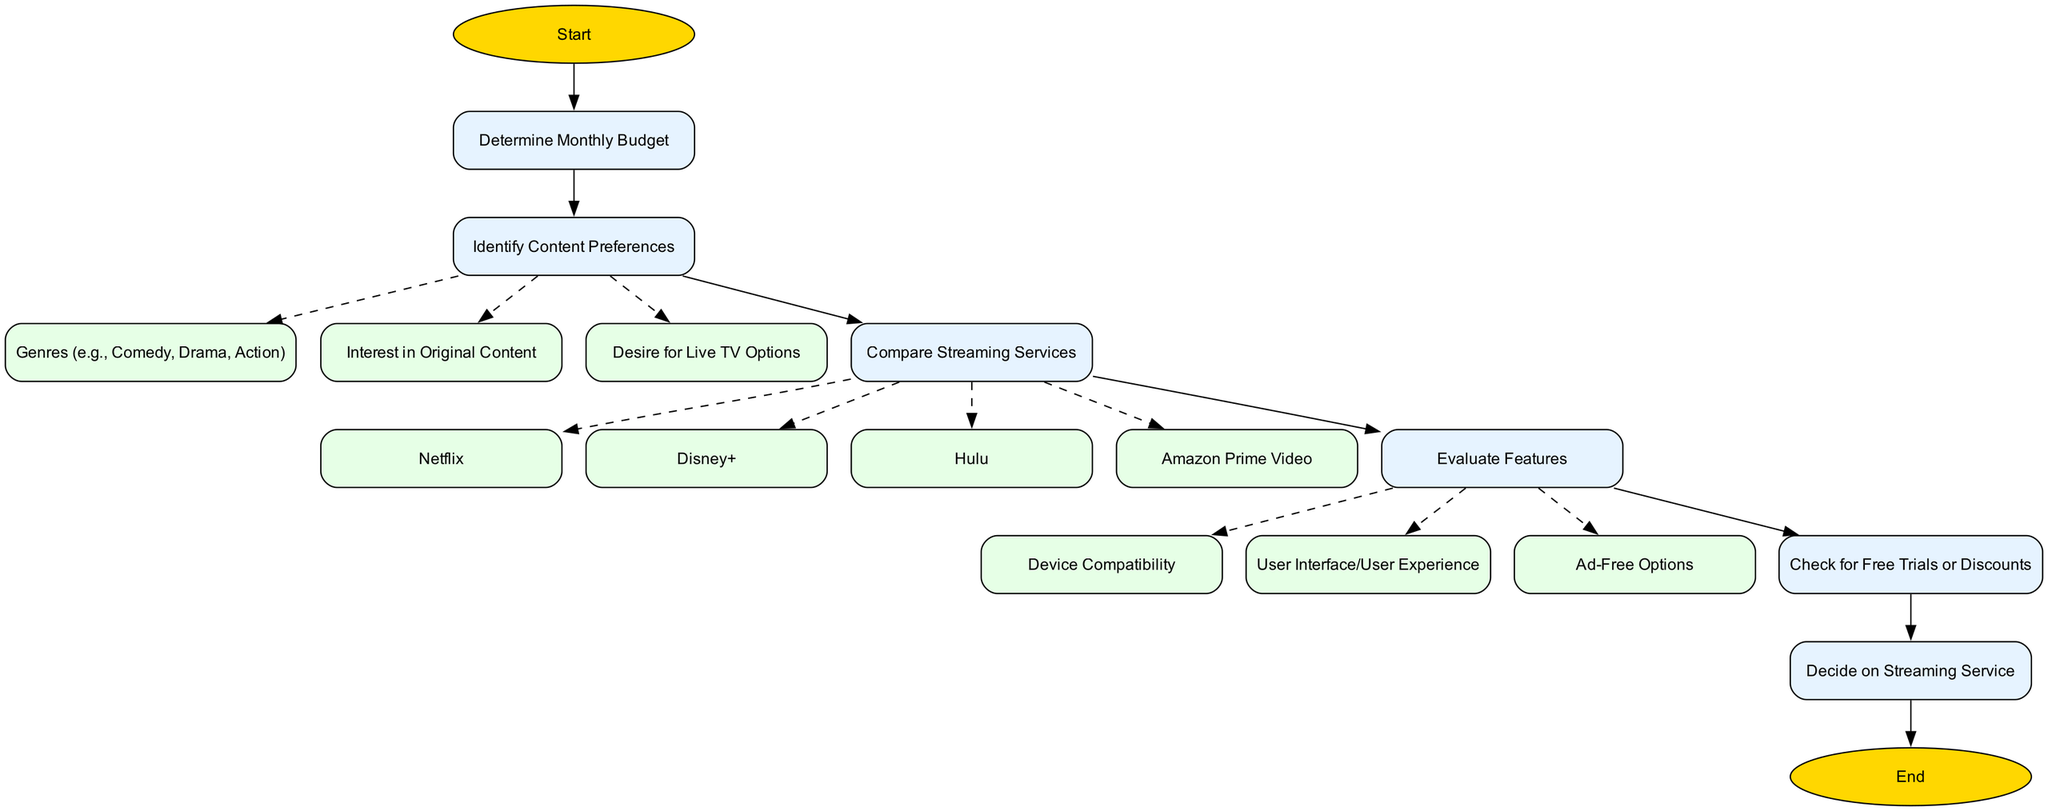What is the first step in the flow chart? The first step in the flow chart is represented by the 'Start' node, from which the process begins. This node connects only to the next step, which is 'Determine Monthly Budget'.
Answer: Start How many streaming services are listed in the comparison step? In the 'Compare Streaming Services' node, there are four options provided: Netflix, Disney+, Hulu, and Amazon Prime Video. Thus, the number of streaming services listed is four.
Answer: Four What node follows the 'Check for Free Trials or Discounts'? After the 'Check for Free Trials or Discounts' step, the flow leads directly to 'Decide on Streaming Service'. This indicates that checking for trials or discounts is a precursor to making a decision.
Answer: Decide on Streaming Service Which feature is evaluated after 'User Interface/User Experience'? The evaluation of features follows a sequence. 'User Interface/User Experience' is considered alongside 'Device Compatibility' and 'Ad-Free Options'. Therefore, the next feature to be evaluated is 'Ad-Free Options'.
Answer: Ad-Free Options What does the 'Identify Content Preferences' step include? This step features three specific elements: 'Genres (e.g., Comedy, Drama, Action)', 'Interest in Original Content', and 'Desire for Live TV Options'. These three categories cover content preference identification.
Answer: Genres, Interest in Original Content, Desire for Live TV Options If a user is developing a budget, which node do they progress to next? Upon determining their monthly budget, users proceed to the 'Identify Content Preferences' node. This means that the next logical step is focused on determining what kind of content the user prefers.
Answer: Identify Content Preferences What shape represents the 'End' node in the flow chart? The ending step in the diagram is denoted by the 'End' node, which is depicted as an oval shape. This design choice contrasts with other nodes that are rectangular, emphasizing its significance as the conclusion of the process.
Answer: Oval How many features are evaluated in the 'Evaluate Features' node? The 'Evaluate Features' node identifies three specific criteria: Device Compatibility, User Interface/User Experience, and Ad-Free Options. Thus, the number of features evaluated is three.
Answer: Three 